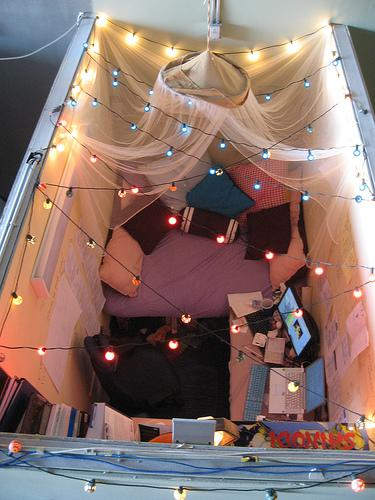Question: where is the picture taken?
Choices:
A. Bedroom.
B. The beach.
C. A mountain.
D. The ski slope.
Answer with the letter. Answer: A Question: how many pillows are on the bed?
Choices:
A. 4.
B. 8.
C. 5.
D. 6.
Answer with the letter. Answer: B Question: what is strung back and forth across the top of the room?
Choices:
A. Streamers.
B. Lights.
C. A clothes line.
D. Ribbons.
Answer with the letter. Answer: B 